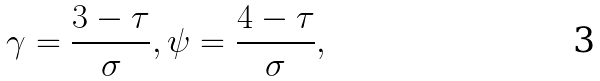<formula> <loc_0><loc_0><loc_500><loc_500>\gamma = \frac { 3 - \tau } { \sigma } , \psi = \frac { 4 - \tau } { \sigma } ,</formula> 